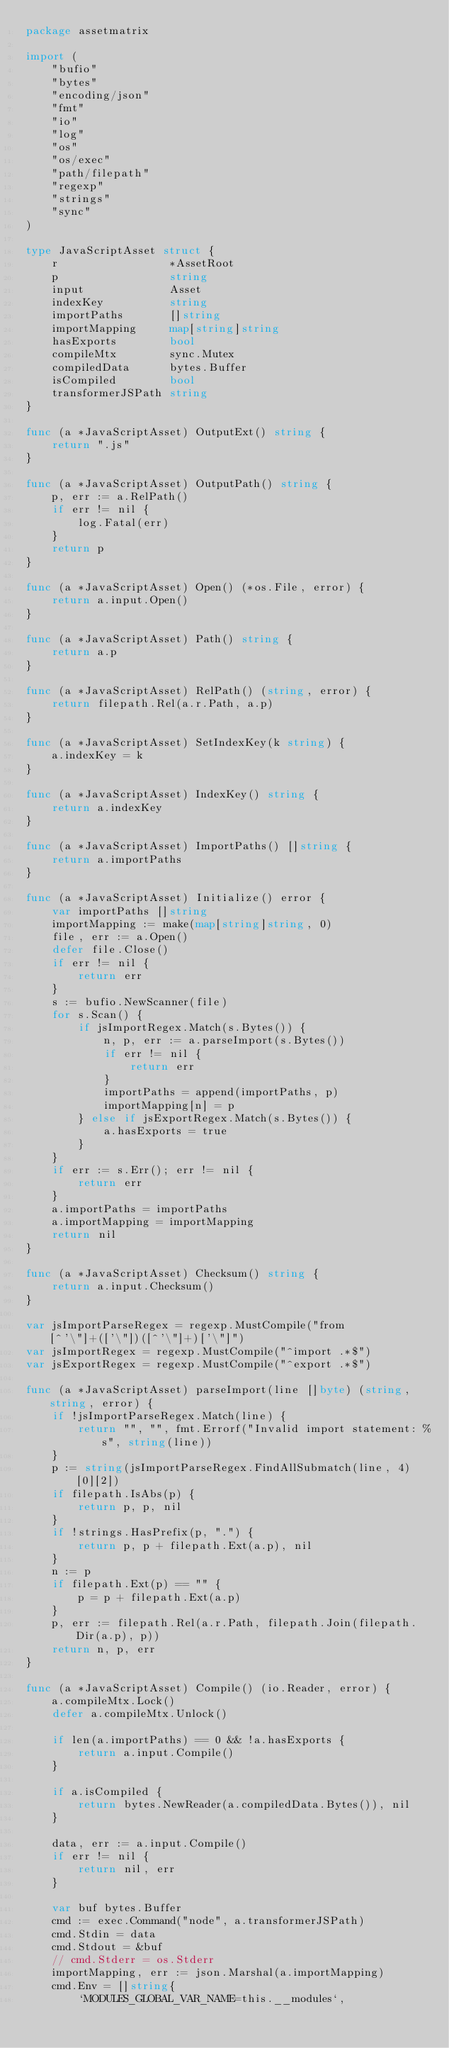Convert code to text. <code><loc_0><loc_0><loc_500><loc_500><_Go_>package assetmatrix

import (
	"bufio"
	"bytes"
	"encoding/json"
	"fmt"
	"io"
	"log"
	"os"
	"os/exec"
	"path/filepath"
	"regexp"
	"strings"
	"sync"
)

type JavaScriptAsset struct {
	r                 *AssetRoot
	p                 string
	input             Asset
	indexKey          string
	importPaths       []string
	importMapping     map[string]string
	hasExports        bool
	compileMtx        sync.Mutex
	compiledData      bytes.Buffer
	isCompiled        bool
	transformerJSPath string
}

func (a *JavaScriptAsset) OutputExt() string {
	return ".js"
}

func (a *JavaScriptAsset) OutputPath() string {
	p, err := a.RelPath()
	if err != nil {
		log.Fatal(err)
	}
	return p
}

func (a *JavaScriptAsset) Open() (*os.File, error) {
	return a.input.Open()
}

func (a *JavaScriptAsset) Path() string {
	return a.p
}

func (a *JavaScriptAsset) RelPath() (string, error) {
	return filepath.Rel(a.r.Path, a.p)
}

func (a *JavaScriptAsset) SetIndexKey(k string) {
	a.indexKey = k
}

func (a *JavaScriptAsset) IndexKey() string {
	return a.indexKey
}

func (a *JavaScriptAsset) ImportPaths() []string {
	return a.importPaths
}

func (a *JavaScriptAsset) Initialize() error {
	var importPaths []string
	importMapping := make(map[string]string, 0)
	file, err := a.Open()
	defer file.Close()
	if err != nil {
		return err
	}
	s := bufio.NewScanner(file)
	for s.Scan() {
		if jsImportRegex.Match(s.Bytes()) {
			n, p, err := a.parseImport(s.Bytes())
			if err != nil {
				return err
			}
			importPaths = append(importPaths, p)
			importMapping[n] = p
		} else if jsExportRegex.Match(s.Bytes()) {
			a.hasExports = true
		}
	}
	if err := s.Err(); err != nil {
		return err
	}
	a.importPaths = importPaths
	a.importMapping = importMapping
	return nil
}

func (a *JavaScriptAsset) Checksum() string {
	return a.input.Checksum()
}

var jsImportParseRegex = regexp.MustCompile("from[^'\"]+(['\"])([^'\"]+)['\"]")
var jsImportRegex = regexp.MustCompile("^import .*$")
var jsExportRegex = regexp.MustCompile("^export .*$")

func (a *JavaScriptAsset) parseImport(line []byte) (string, string, error) {
	if !jsImportParseRegex.Match(line) {
		return "", "", fmt.Errorf("Invalid import statement: %s", string(line))
	}
	p := string(jsImportParseRegex.FindAllSubmatch(line, 4)[0][2])
	if filepath.IsAbs(p) {
		return p, p, nil
	}
	if !strings.HasPrefix(p, ".") {
		return p, p + filepath.Ext(a.p), nil
	}
	n := p
	if filepath.Ext(p) == "" {
		p = p + filepath.Ext(a.p)
	}
	p, err := filepath.Rel(a.r.Path, filepath.Join(filepath.Dir(a.p), p))
	return n, p, err
}

func (a *JavaScriptAsset) Compile() (io.Reader, error) {
	a.compileMtx.Lock()
	defer a.compileMtx.Unlock()

	if len(a.importPaths) == 0 && !a.hasExports {
		return a.input.Compile()
	}

	if a.isCompiled {
		return bytes.NewReader(a.compiledData.Bytes()), nil
	}

	data, err := a.input.Compile()
	if err != nil {
		return nil, err
	}

	var buf bytes.Buffer
	cmd := exec.Command("node", a.transformerJSPath)
	cmd.Stdin = data
	cmd.Stdout = &buf
	// cmd.Stderr = os.Stderr
	importMapping, err := json.Marshal(a.importMapping)
	cmd.Env = []string{
		`MODULES_GLOBAL_VAR_NAME=this.__modules`,</code> 